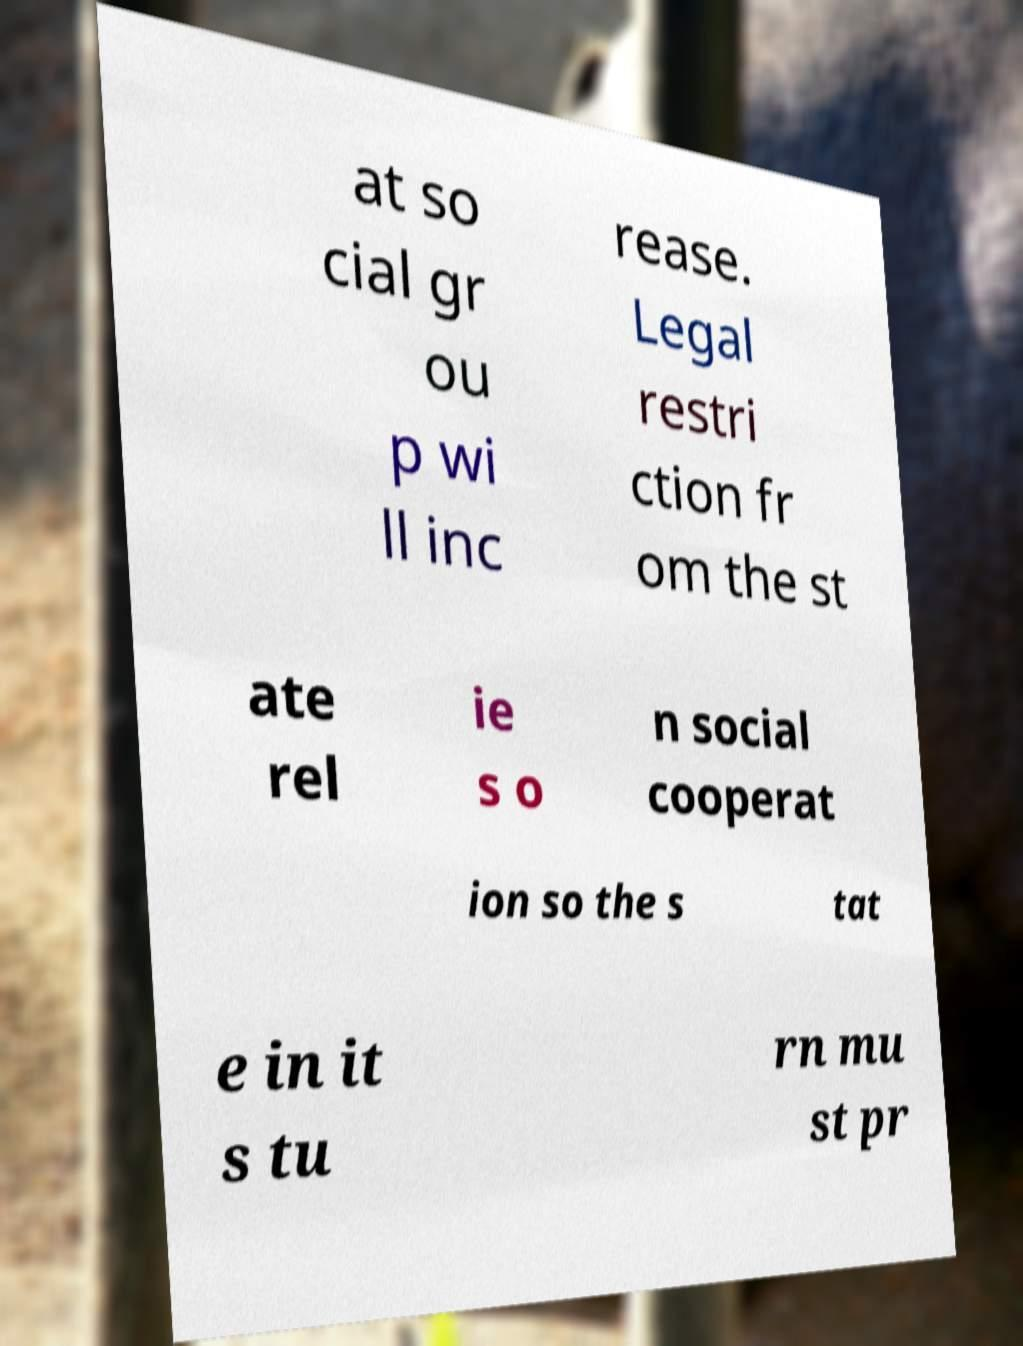Please identify and transcribe the text found in this image. at so cial gr ou p wi ll inc rease. Legal restri ction fr om the st ate rel ie s o n social cooperat ion so the s tat e in it s tu rn mu st pr 